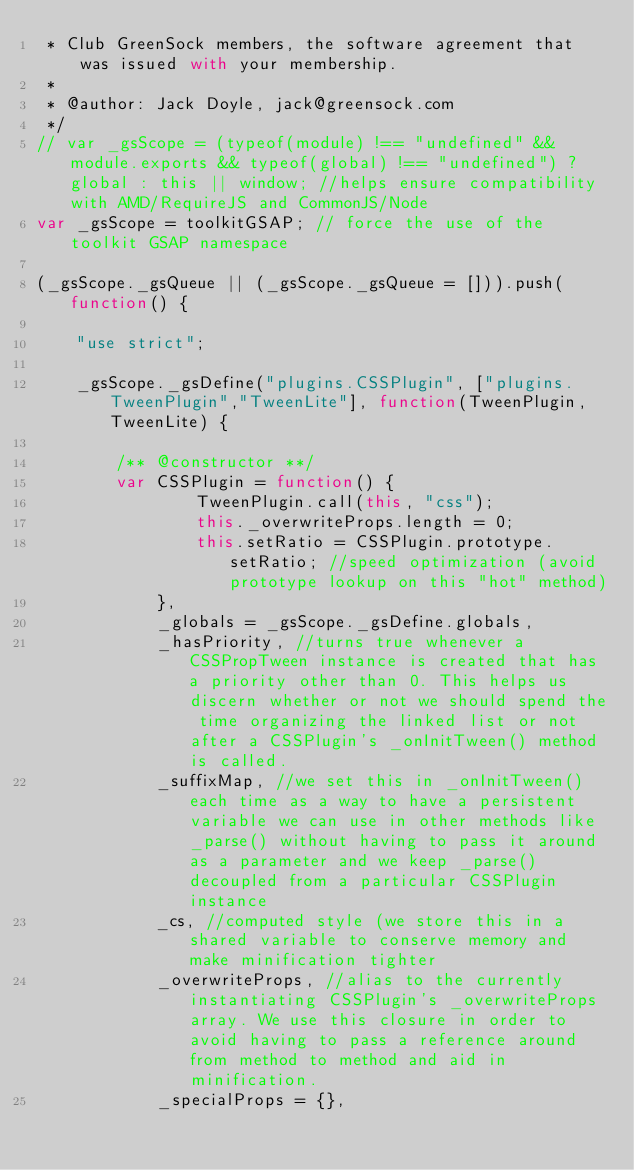Convert code to text. <code><loc_0><loc_0><loc_500><loc_500><_JavaScript_> * Club GreenSock members, the software agreement that was issued with your membership.
 * 
 * @author: Jack Doyle, jack@greensock.com
 */
// var _gsScope = (typeof(module) !== "undefined" && module.exports && typeof(global) !== "undefined") ? global : this || window; //helps ensure compatibility with AMD/RequireJS and CommonJS/Node
var _gsScope = toolkitGSAP; // force the use of the toolkit GSAP namespace

(_gsScope._gsQueue || (_gsScope._gsQueue = [])).push( function() {

	"use strict";

	_gsScope._gsDefine("plugins.CSSPlugin", ["plugins.TweenPlugin","TweenLite"], function(TweenPlugin, TweenLite) {

		/** @constructor **/
		var CSSPlugin = function() {
				TweenPlugin.call(this, "css");
				this._overwriteProps.length = 0;
				this.setRatio = CSSPlugin.prototype.setRatio; //speed optimization (avoid prototype lookup on this "hot" method)
			},
			_globals = _gsScope._gsDefine.globals,
			_hasPriority, //turns true whenever a CSSPropTween instance is created that has a priority other than 0. This helps us discern whether or not we should spend the time organizing the linked list or not after a CSSPlugin's _onInitTween() method is called.
			_suffixMap, //we set this in _onInitTween() each time as a way to have a persistent variable we can use in other methods like _parse() without having to pass it around as a parameter and we keep _parse() decoupled from a particular CSSPlugin instance
			_cs, //computed style (we store this in a shared variable to conserve memory and make minification tighter
			_overwriteProps, //alias to the currently instantiating CSSPlugin's _overwriteProps array. We use this closure in order to avoid having to pass a reference around from method to method and aid in minification.
			_specialProps = {},</code> 